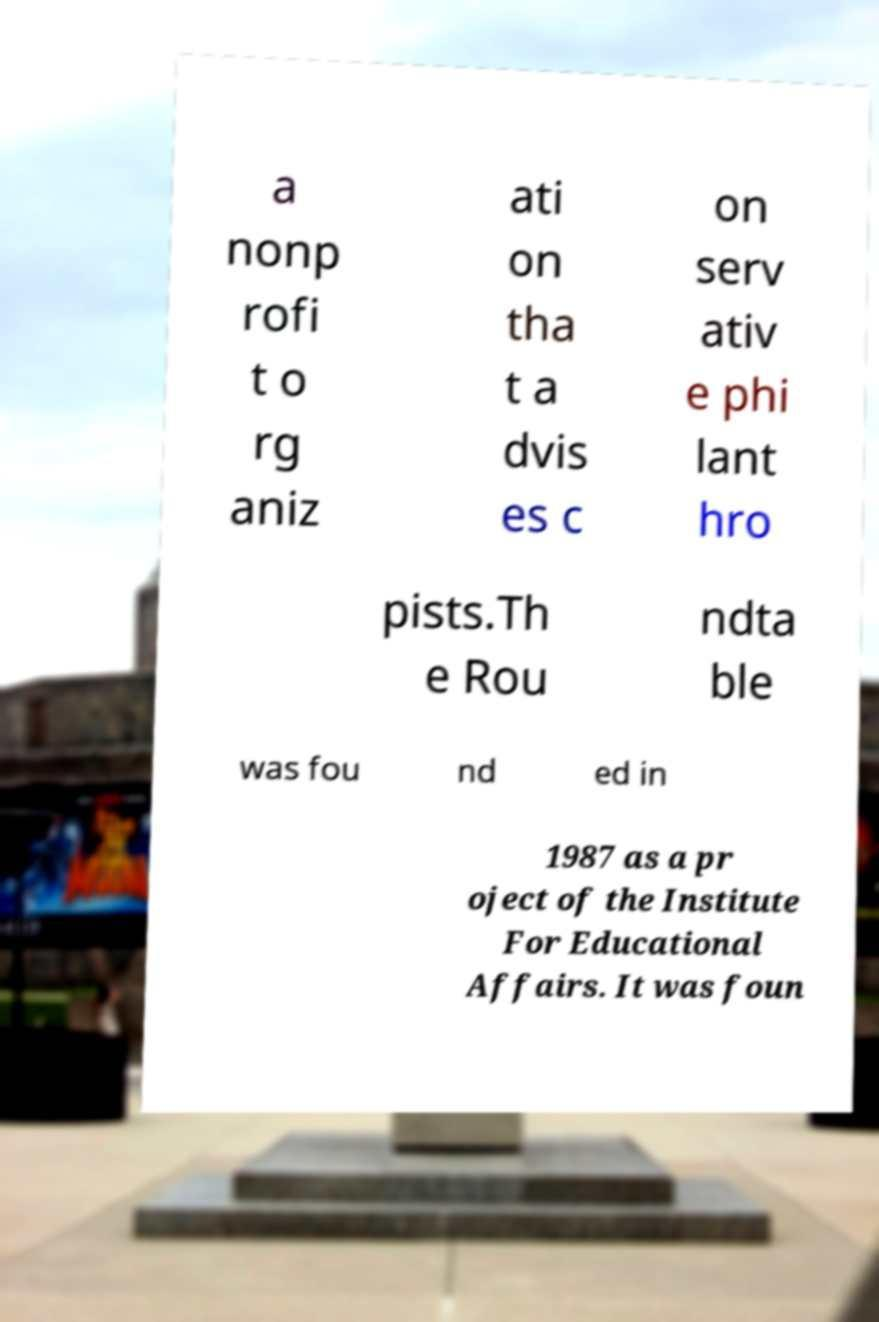Please identify and transcribe the text found in this image. a nonp rofi t o rg aniz ati on tha t a dvis es c on serv ativ e phi lant hro pists.Th e Rou ndta ble was fou nd ed in 1987 as a pr oject of the Institute For Educational Affairs. It was foun 